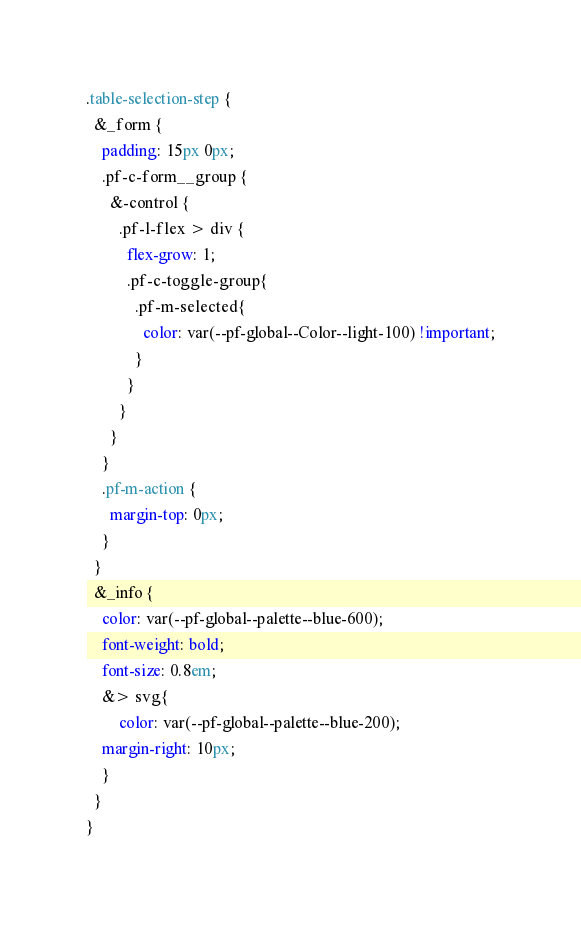<code> <loc_0><loc_0><loc_500><loc_500><_CSS_>.table-selection-step {
  &_form {
    padding: 15px 0px;
    .pf-c-form__group {
      &-control {
        .pf-l-flex > div {
          flex-grow: 1;
          .pf-c-toggle-group{
            .pf-m-selected{
              color: var(--pf-global--Color--light-100) !important;
            }
          }
        }
      }
    }
    .pf-m-action {
      margin-top: 0px;
    }
  }
  &_info {
    color: var(--pf-global--palette--blue-600);
    font-weight: bold;
    font-size: 0.8em;
    &> svg{
        color: var(--pf-global--palette--blue-200);
    margin-right: 10px;
    }
  }
}
</code> 